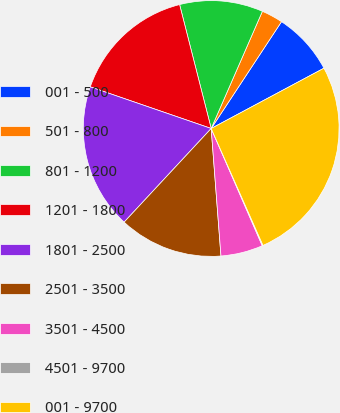<chart> <loc_0><loc_0><loc_500><loc_500><pie_chart><fcel>001 - 500<fcel>501 - 800<fcel>801 - 1200<fcel>1201 - 1800<fcel>1801 - 2500<fcel>2501 - 3500<fcel>3501 - 4500<fcel>4501 - 9700<fcel>001 - 9700<nl><fcel>7.92%<fcel>2.71%<fcel>10.53%<fcel>15.75%<fcel>18.36%<fcel>13.14%<fcel>5.32%<fcel>0.1%<fcel>26.18%<nl></chart> 